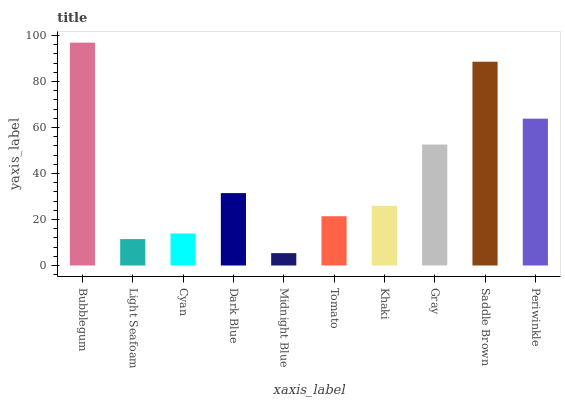Is Midnight Blue the minimum?
Answer yes or no. Yes. Is Bubblegum the maximum?
Answer yes or no. Yes. Is Light Seafoam the minimum?
Answer yes or no. No. Is Light Seafoam the maximum?
Answer yes or no. No. Is Bubblegum greater than Light Seafoam?
Answer yes or no. Yes. Is Light Seafoam less than Bubblegum?
Answer yes or no. Yes. Is Light Seafoam greater than Bubblegum?
Answer yes or no. No. Is Bubblegum less than Light Seafoam?
Answer yes or no. No. Is Dark Blue the high median?
Answer yes or no. Yes. Is Khaki the low median?
Answer yes or no. Yes. Is Tomato the high median?
Answer yes or no. No. Is Gray the low median?
Answer yes or no. No. 